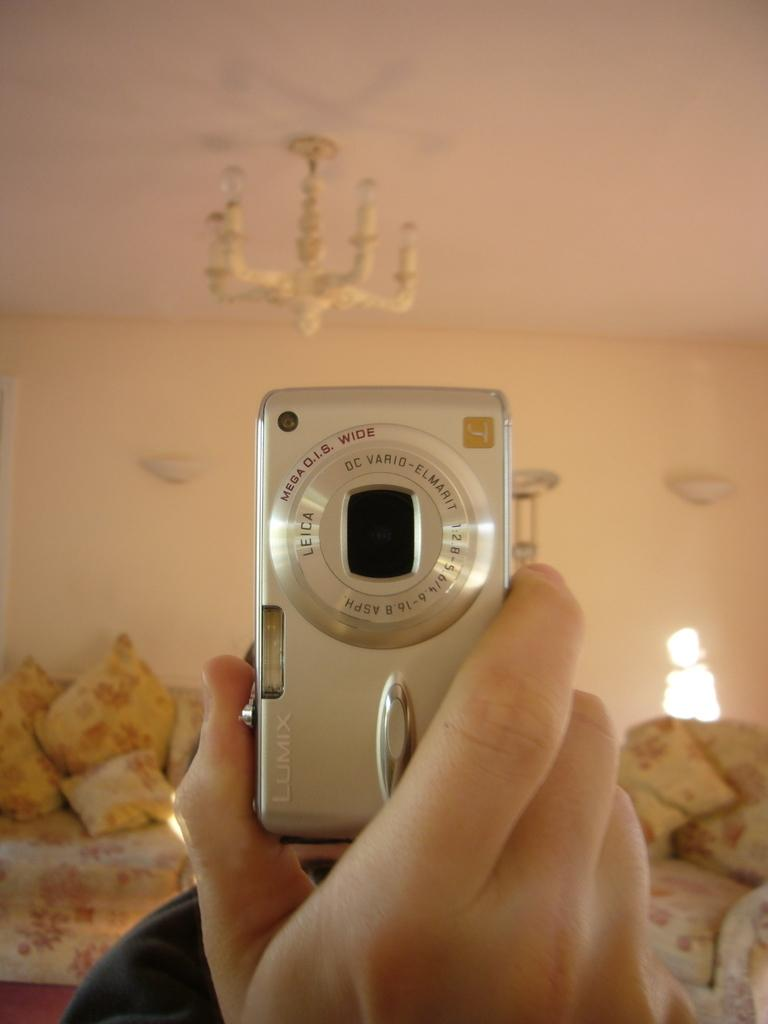What is the person in the image holding? There is a hand holding a camera in the image. What type of furniture can be seen in the image? There is a chair and a couch in the image. What is hanging from the ceiling in the image? There is a chandelier in the image. What is visible in the background of the image? There is a wall in the background of the image. What type of owl can be seen sitting on the chandelier in the image? There is no owl present in the image; it only features a hand holding a camera, pillows, a chair, a couch, a chandelier, and a wall. 